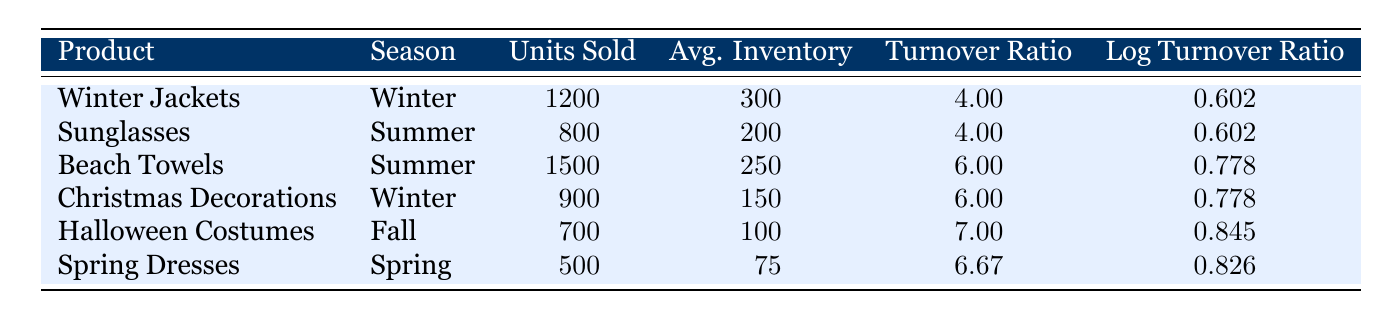What is the turnover ratio for Spring Dresses? The turnover ratio for Spring Dresses is explicitly listed in the table under the corresponding column, which shows a value of 6.67.
Answer: 6.67 Which product has the highest number of units sold during the Summer season? By examining the units sold for Summer products, we compare Sunglasses and Beach Towels. Beach Towels has 1500 units sold, which is higher than 800 units sold for Sunglasses.
Answer: Beach Towels Is the average inventory for Halloween Costumes greater than that of Beach Towels? The average inventory for Halloween Costumes is 100, while for Beach Towels it is 250. Since 100 is less than 250, the statement is false.
Answer: No What is the total number of units sold for all Winter products? The Winter products are Winter Jackets (1200 units) and Christmas Decorations (900 units). Adding these gives 1200 + 900 = 2100 units sold in total for Winter.
Answer: 2100 Which product has the lowest turnover ratio? A review of the turnover ratios reveals that Winter Jackets and Sunglasses both have a turnover ratio of 4.00, the lowest among the listed products.
Answer: Winter Jackets or Sunglasses What is the average turnover ratio for products sold in Fall and Spring seasons? The turnover ratios for Halloween Costumes (7.0) and Spring Dresses (6.67) are averaged by summing them (7.0 + 6.67 = 13.67) and then dividing by 2, which results in 13.67 / 2 = 6.835.
Answer: 6.835 Do both products for the Summer season have the same log turnover ratio? Looking at the log turnover ratios for Summer products, both Sunglasses and Beach Towels have a log turnover ratio of 0.602 for Sunglasses and 0.778 for Beach Towels. Since these values are different, the statement is false.
Answer: No Which season had the highest average turnover ratio across all products? We calculate the average turnover ratio for each season: Winter (4.00 + 6.00 = 10.00, average = 5.00), Summer (4.00 + 6.00 = 10.00, average = 5.00), Fall (7.00), and Spring (6.67). The highest average turnover ratio is in Fall (7.00).
Answer: Fall Is the log turnover ratio for Spring Dresses closer to that of Winter Jackets than to Beach Towels? The log turnover ratio for Spring Dresses is 0.826, for Winter Jackets it is 0.602, and for Beach Towels it is 0.778. The differences are abs(0.826 - 0.602) = 0.224 and abs(0.826 - 0.778) = 0.048. Since 0.048 is less than 0.224, it's closer to Beach Towels.
Answer: No 